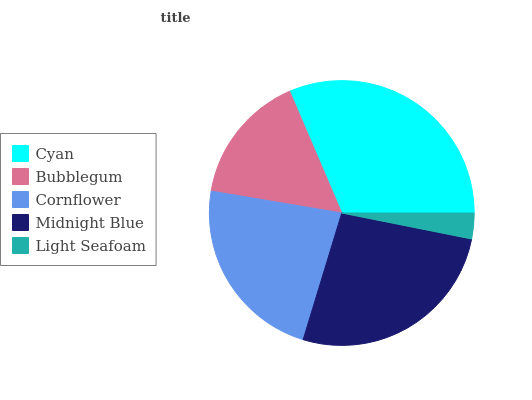Is Light Seafoam the minimum?
Answer yes or no. Yes. Is Cyan the maximum?
Answer yes or no. Yes. Is Bubblegum the minimum?
Answer yes or no. No. Is Bubblegum the maximum?
Answer yes or no. No. Is Cyan greater than Bubblegum?
Answer yes or no. Yes. Is Bubblegum less than Cyan?
Answer yes or no. Yes. Is Bubblegum greater than Cyan?
Answer yes or no. No. Is Cyan less than Bubblegum?
Answer yes or no. No. Is Cornflower the high median?
Answer yes or no. Yes. Is Cornflower the low median?
Answer yes or no. Yes. Is Cyan the high median?
Answer yes or no. No. Is Bubblegum the low median?
Answer yes or no. No. 